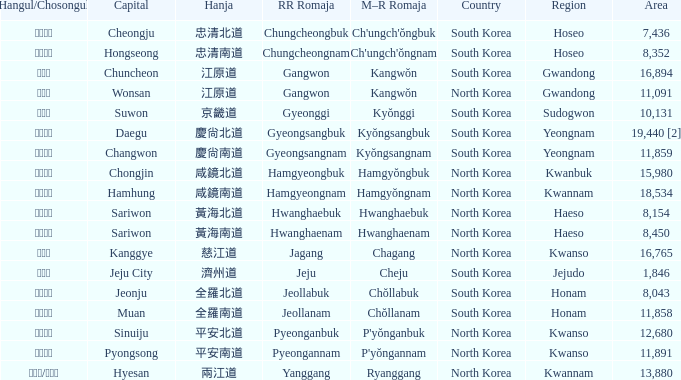Which country has a city with a Hanja of 平安北道? North Korea. 